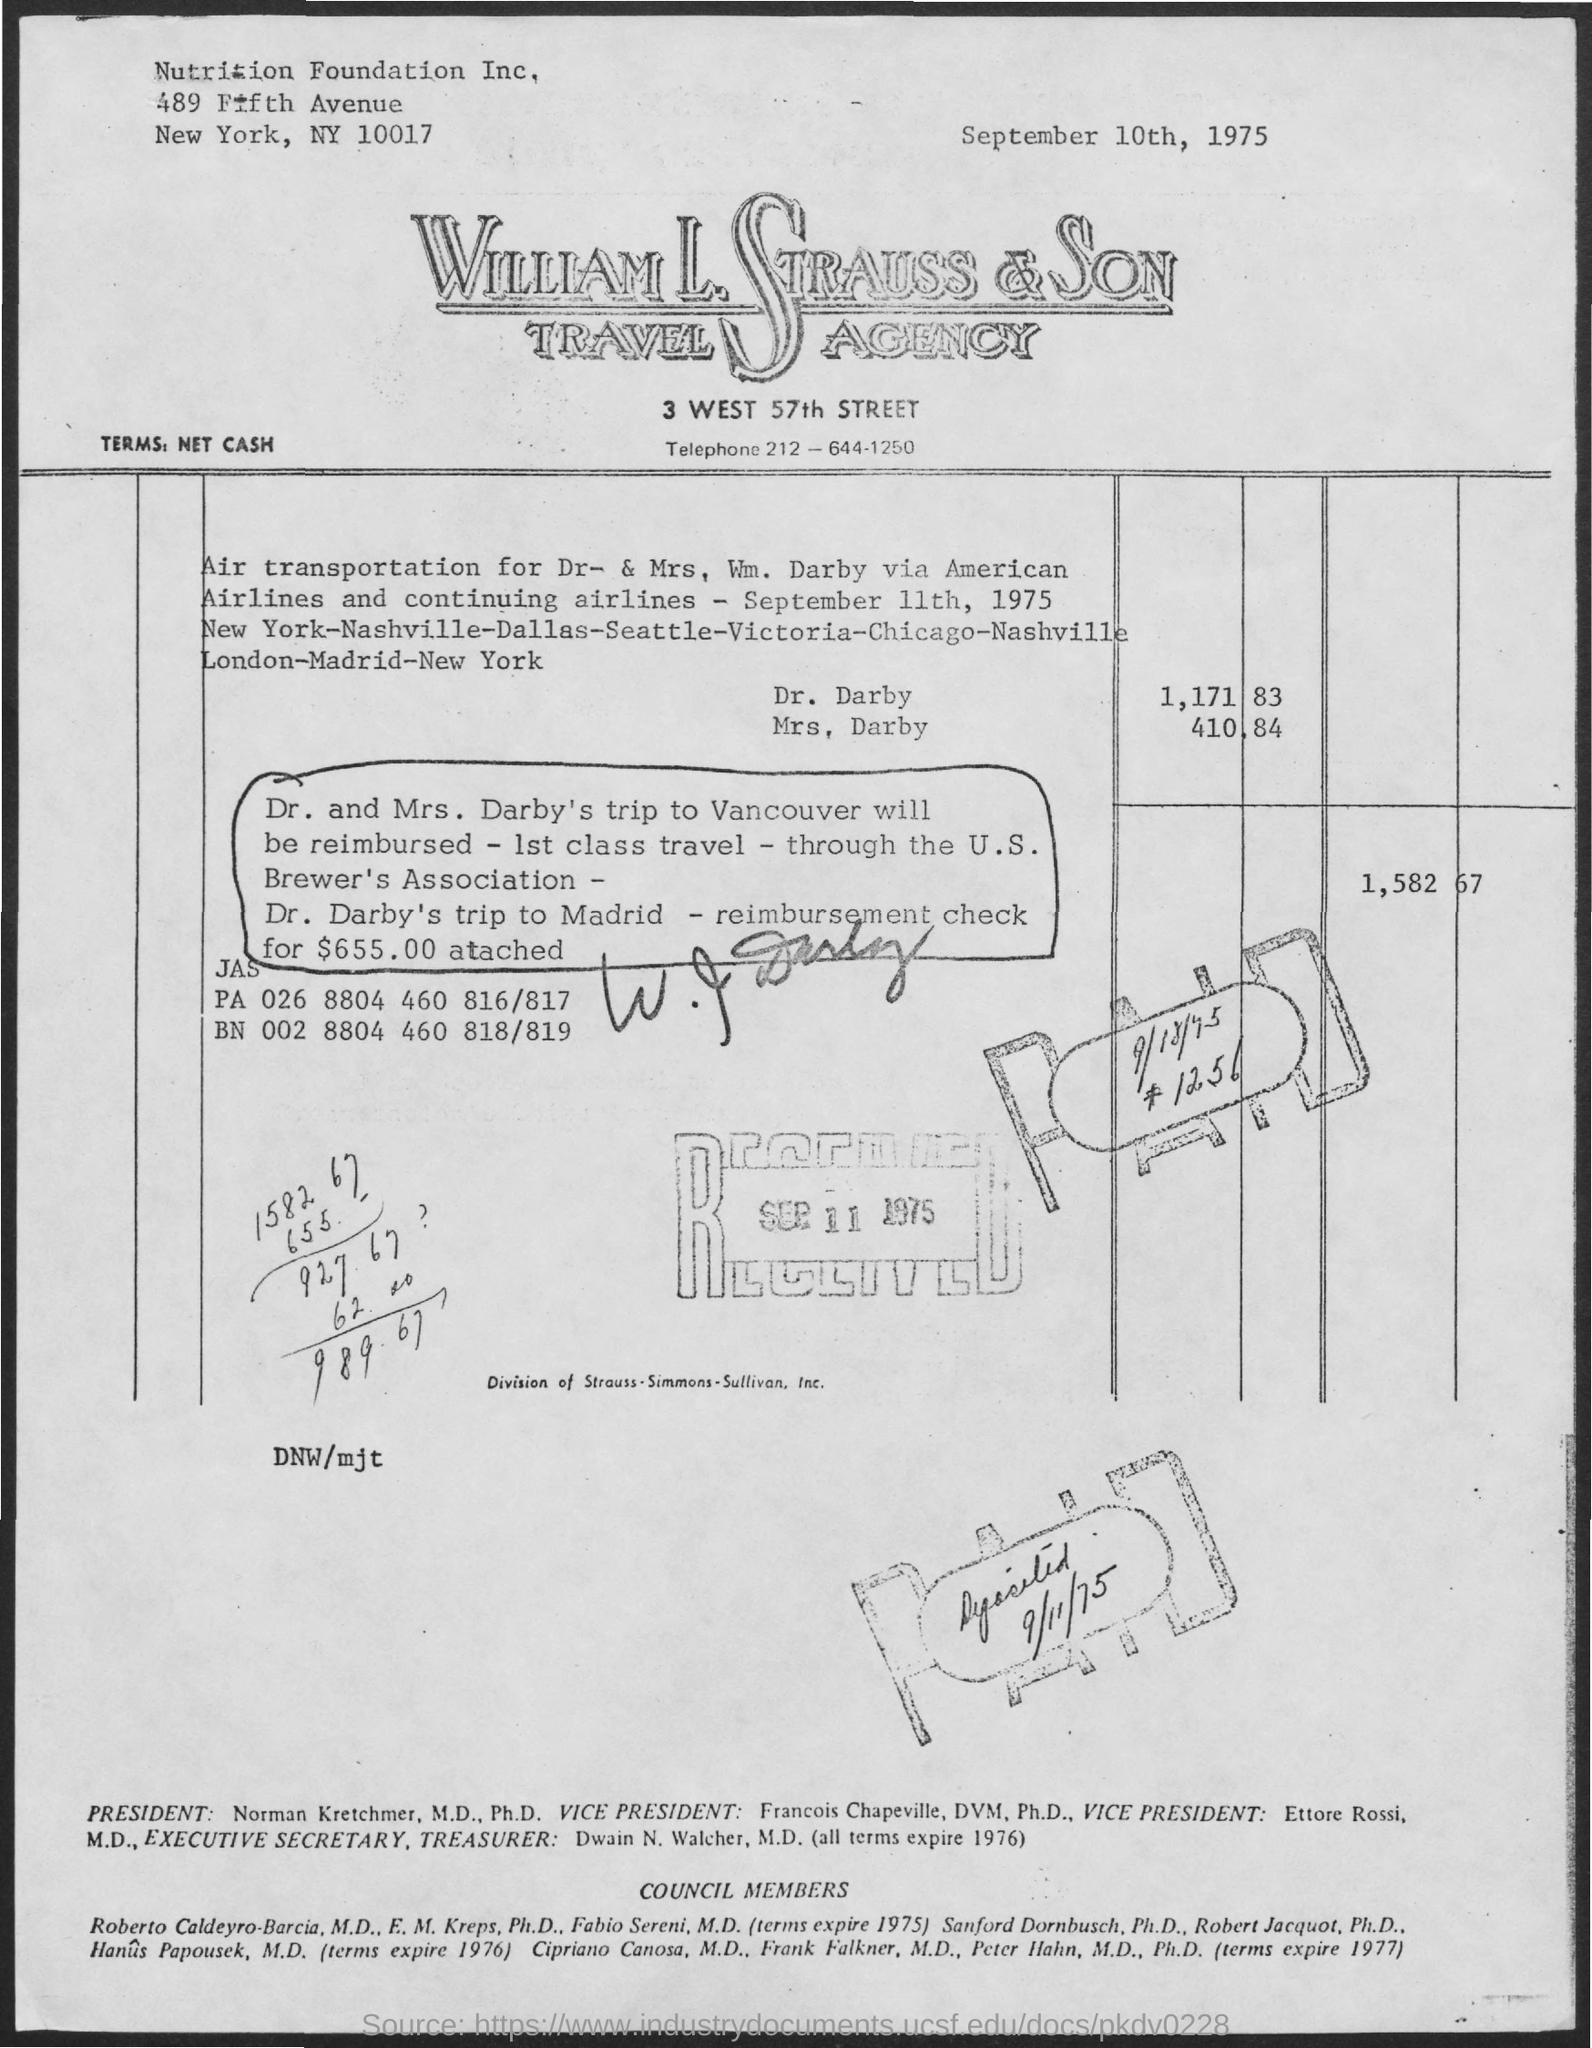What is the telephone number of william l. strauss & son travel agency?
Your response must be concise. 212-644-1250. What is the postal code of ny?
Give a very brief answer. 10017. What is the date mentioned in the bill at top?
Your answer should be very brief. SEPTEMBER 10TH, 1975. 